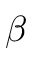Convert formula to latex. <formula><loc_0><loc_0><loc_500><loc_500>\beta</formula> 